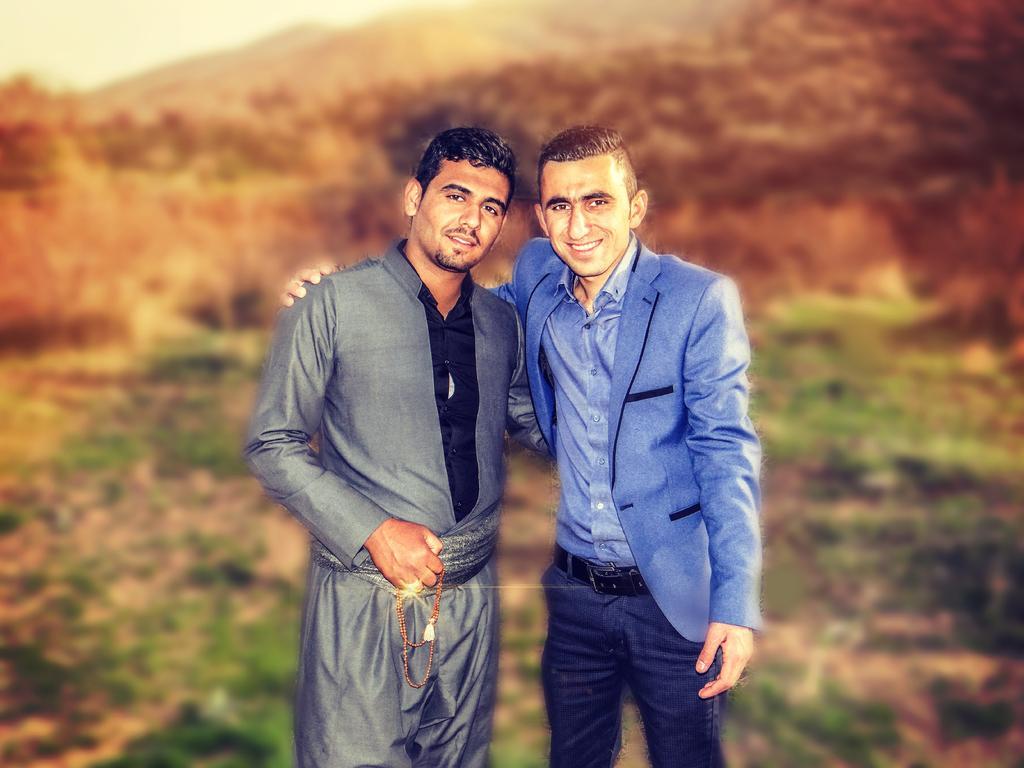In one or two sentences, can you explain what this image depicts? In this image in front there are two people. Behind them there are mountains. At the bottom of the image there is grass on the surface. In the background of the image there is sky. 